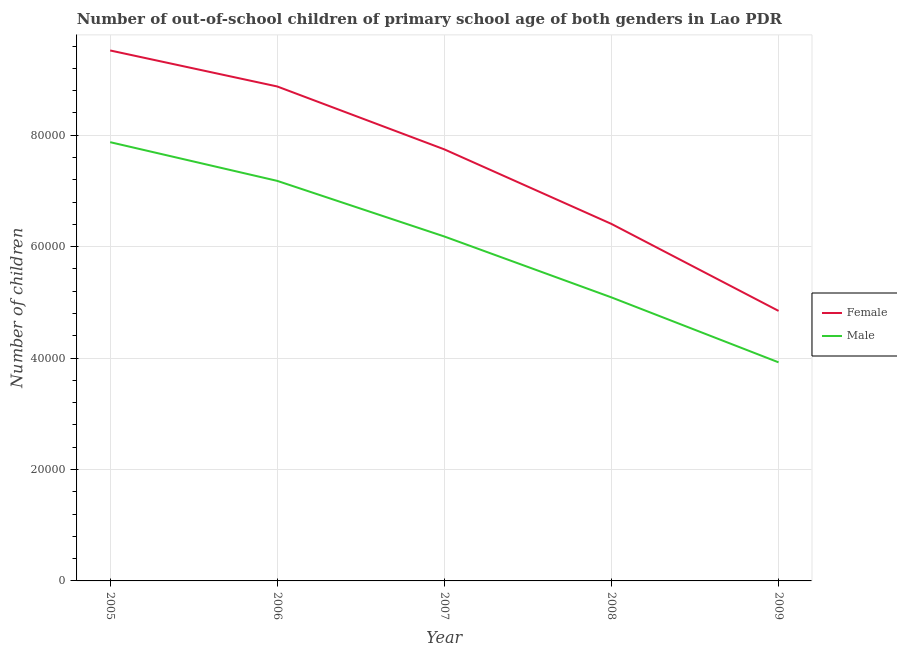Does the line corresponding to number of male out-of-school students intersect with the line corresponding to number of female out-of-school students?
Your answer should be compact. No. Is the number of lines equal to the number of legend labels?
Provide a short and direct response. Yes. What is the number of female out-of-school students in 2008?
Provide a short and direct response. 6.41e+04. Across all years, what is the maximum number of male out-of-school students?
Provide a succinct answer. 7.87e+04. Across all years, what is the minimum number of female out-of-school students?
Make the answer very short. 4.85e+04. In which year was the number of female out-of-school students maximum?
Give a very brief answer. 2005. In which year was the number of male out-of-school students minimum?
Your answer should be very brief. 2009. What is the total number of female out-of-school students in the graph?
Your response must be concise. 3.74e+05. What is the difference between the number of female out-of-school students in 2005 and that in 2009?
Offer a very short reply. 4.67e+04. What is the difference between the number of female out-of-school students in 2009 and the number of male out-of-school students in 2007?
Provide a short and direct response. -1.34e+04. What is the average number of female out-of-school students per year?
Keep it short and to the point. 7.48e+04. In the year 2008, what is the difference between the number of male out-of-school students and number of female out-of-school students?
Provide a short and direct response. -1.32e+04. What is the ratio of the number of female out-of-school students in 2005 to that in 2008?
Your response must be concise. 1.49. Is the number of male out-of-school students in 2007 less than that in 2008?
Provide a short and direct response. No. What is the difference between the highest and the second highest number of female out-of-school students?
Provide a succinct answer. 6463. What is the difference between the highest and the lowest number of female out-of-school students?
Provide a short and direct response. 4.67e+04. In how many years, is the number of male out-of-school students greater than the average number of male out-of-school students taken over all years?
Give a very brief answer. 3. Does the number of female out-of-school students monotonically increase over the years?
Give a very brief answer. No. How many years are there in the graph?
Your answer should be compact. 5. What is the difference between two consecutive major ticks on the Y-axis?
Offer a very short reply. 2.00e+04. Where does the legend appear in the graph?
Keep it short and to the point. Center right. How are the legend labels stacked?
Offer a very short reply. Vertical. What is the title of the graph?
Give a very brief answer. Number of out-of-school children of primary school age of both genders in Lao PDR. Does "Constant 2005 US$" appear as one of the legend labels in the graph?
Give a very brief answer. No. What is the label or title of the X-axis?
Your answer should be compact. Year. What is the label or title of the Y-axis?
Ensure brevity in your answer.  Number of children. What is the Number of children of Female in 2005?
Provide a short and direct response. 9.52e+04. What is the Number of children of Male in 2005?
Give a very brief answer. 7.87e+04. What is the Number of children of Female in 2006?
Give a very brief answer. 8.87e+04. What is the Number of children in Male in 2006?
Offer a terse response. 7.18e+04. What is the Number of children in Female in 2007?
Keep it short and to the point. 7.74e+04. What is the Number of children in Male in 2007?
Offer a terse response. 6.18e+04. What is the Number of children in Female in 2008?
Offer a very short reply. 6.41e+04. What is the Number of children of Male in 2008?
Provide a short and direct response. 5.09e+04. What is the Number of children of Female in 2009?
Give a very brief answer. 4.85e+04. What is the Number of children of Male in 2009?
Provide a short and direct response. 3.92e+04. Across all years, what is the maximum Number of children of Female?
Provide a succinct answer. 9.52e+04. Across all years, what is the maximum Number of children in Male?
Provide a short and direct response. 7.87e+04. Across all years, what is the minimum Number of children of Female?
Provide a succinct answer. 4.85e+04. Across all years, what is the minimum Number of children of Male?
Your answer should be compact. 3.92e+04. What is the total Number of children of Female in the graph?
Offer a very short reply. 3.74e+05. What is the total Number of children of Male in the graph?
Provide a succinct answer. 3.02e+05. What is the difference between the Number of children in Female in 2005 and that in 2006?
Ensure brevity in your answer.  6463. What is the difference between the Number of children of Male in 2005 and that in 2006?
Provide a succinct answer. 6947. What is the difference between the Number of children in Female in 2005 and that in 2007?
Provide a short and direct response. 1.78e+04. What is the difference between the Number of children in Male in 2005 and that in 2007?
Provide a succinct answer. 1.69e+04. What is the difference between the Number of children of Female in 2005 and that in 2008?
Give a very brief answer. 3.11e+04. What is the difference between the Number of children in Male in 2005 and that in 2008?
Ensure brevity in your answer.  2.79e+04. What is the difference between the Number of children in Female in 2005 and that in 2009?
Make the answer very short. 4.67e+04. What is the difference between the Number of children of Male in 2005 and that in 2009?
Provide a short and direct response. 3.95e+04. What is the difference between the Number of children in Female in 2006 and that in 2007?
Provide a succinct answer. 1.13e+04. What is the difference between the Number of children in Male in 2006 and that in 2007?
Your response must be concise. 9980. What is the difference between the Number of children of Female in 2006 and that in 2008?
Make the answer very short. 2.47e+04. What is the difference between the Number of children in Male in 2006 and that in 2008?
Offer a terse response. 2.09e+04. What is the difference between the Number of children of Female in 2006 and that in 2009?
Make the answer very short. 4.03e+04. What is the difference between the Number of children of Male in 2006 and that in 2009?
Your response must be concise. 3.26e+04. What is the difference between the Number of children of Female in 2007 and that in 2008?
Make the answer very short. 1.34e+04. What is the difference between the Number of children of Male in 2007 and that in 2008?
Your response must be concise. 1.09e+04. What is the difference between the Number of children in Female in 2007 and that in 2009?
Give a very brief answer. 2.90e+04. What is the difference between the Number of children in Male in 2007 and that in 2009?
Your answer should be compact. 2.26e+04. What is the difference between the Number of children in Female in 2008 and that in 2009?
Your response must be concise. 1.56e+04. What is the difference between the Number of children of Male in 2008 and that in 2009?
Your answer should be very brief. 1.17e+04. What is the difference between the Number of children of Female in 2005 and the Number of children of Male in 2006?
Offer a very short reply. 2.34e+04. What is the difference between the Number of children of Female in 2005 and the Number of children of Male in 2007?
Your response must be concise. 3.34e+04. What is the difference between the Number of children in Female in 2005 and the Number of children in Male in 2008?
Make the answer very short. 4.43e+04. What is the difference between the Number of children of Female in 2005 and the Number of children of Male in 2009?
Your response must be concise. 5.60e+04. What is the difference between the Number of children in Female in 2006 and the Number of children in Male in 2007?
Ensure brevity in your answer.  2.69e+04. What is the difference between the Number of children in Female in 2006 and the Number of children in Male in 2008?
Ensure brevity in your answer.  3.79e+04. What is the difference between the Number of children of Female in 2006 and the Number of children of Male in 2009?
Your answer should be compact. 4.95e+04. What is the difference between the Number of children of Female in 2007 and the Number of children of Male in 2008?
Provide a short and direct response. 2.66e+04. What is the difference between the Number of children of Female in 2007 and the Number of children of Male in 2009?
Your answer should be very brief. 3.82e+04. What is the difference between the Number of children of Female in 2008 and the Number of children of Male in 2009?
Offer a terse response. 2.48e+04. What is the average Number of children of Female per year?
Give a very brief answer. 7.48e+04. What is the average Number of children in Male per year?
Your answer should be very brief. 6.05e+04. In the year 2005, what is the difference between the Number of children in Female and Number of children in Male?
Your answer should be very brief. 1.65e+04. In the year 2006, what is the difference between the Number of children of Female and Number of children of Male?
Offer a terse response. 1.69e+04. In the year 2007, what is the difference between the Number of children of Female and Number of children of Male?
Provide a succinct answer. 1.56e+04. In the year 2008, what is the difference between the Number of children in Female and Number of children in Male?
Your response must be concise. 1.32e+04. In the year 2009, what is the difference between the Number of children in Female and Number of children in Male?
Provide a short and direct response. 9231. What is the ratio of the Number of children in Female in 2005 to that in 2006?
Your answer should be very brief. 1.07. What is the ratio of the Number of children in Male in 2005 to that in 2006?
Offer a very short reply. 1.1. What is the ratio of the Number of children of Female in 2005 to that in 2007?
Make the answer very short. 1.23. What is the ratio of the Number of children of Male in 2005 to that in 2007?
Offer a terse response. 1.27. What is the ratio of the Number of children of Female in 2005 to that in 2008?
Offer a terse response. 1.49. What is the ratio of the Number of children in Male in 2005 to that in 2008?
Offer a terse response. 1.55. What is the ratio of the Number of children in Female in 2005 to that in 2009?
Provide a short and direct response. 1.96. What is the ratio of the Number of children of Male in 2005 to that in 2009?
Offer a very short reply. 2.01. What is the ratio of the Number of children of Female in 2006 to that in 2007?
Offer a very short reply. 1.15. What is the ratio of the Number of children of Male in 2006 to that in 2007?
Provide a short and direct response. 1.16. What is the ratio of the Number of children of Female in 2006 to that in 2008?
Keep it short and to the point. 1.39. What is the ratio of the Number of children in Male in 2006 to that in 2008?
Your answer should be compact. 1.41. What is the ratio of the Number of children of Female in 2006 to that in 2009?
Provide a short and direct response. 1.83. What is the ratio of the Number of children in Male in 2006 to that in 2009?
Ensure brevity in your answer.  1.83. What is the ratio of the Number of children in Female in 2007 to that in 2008?
Ensure brevity in your answer.  1.21. What is the ratio of the Number of children of Male in 2007 to that in 2008?
Make the answer very short. 1.21. What is the ratio of the Number of children of Female in 2007 to that in 2009?
Your answer should be very brief. 1.6. What is the ratio of the Number of children in Male in 2007 to that in 2009?
Your answer should be very brief. 1.58. What is the ratio of the Number of children of Female in 2008 to that in 2009?
Offer a terse response. 1.32. What is the ratio of the Number of children in Male in 2008 to that in 2009?
Make the answer very short. 1.3. What is the difference between the highest and the second highest Number of children of Female?
Make the answer very short. 6463. What is the difference between the highest and the second highest Number of children in Male?
Your response must be concise. 6947. What is the difference between the highest and the lowest Number of children of Female?
Your answer should be very brief. 4.67e+04. What is the difference between the highest and the lowest Number of children of Male?
Your answer should be compact. 3.95e+04. 